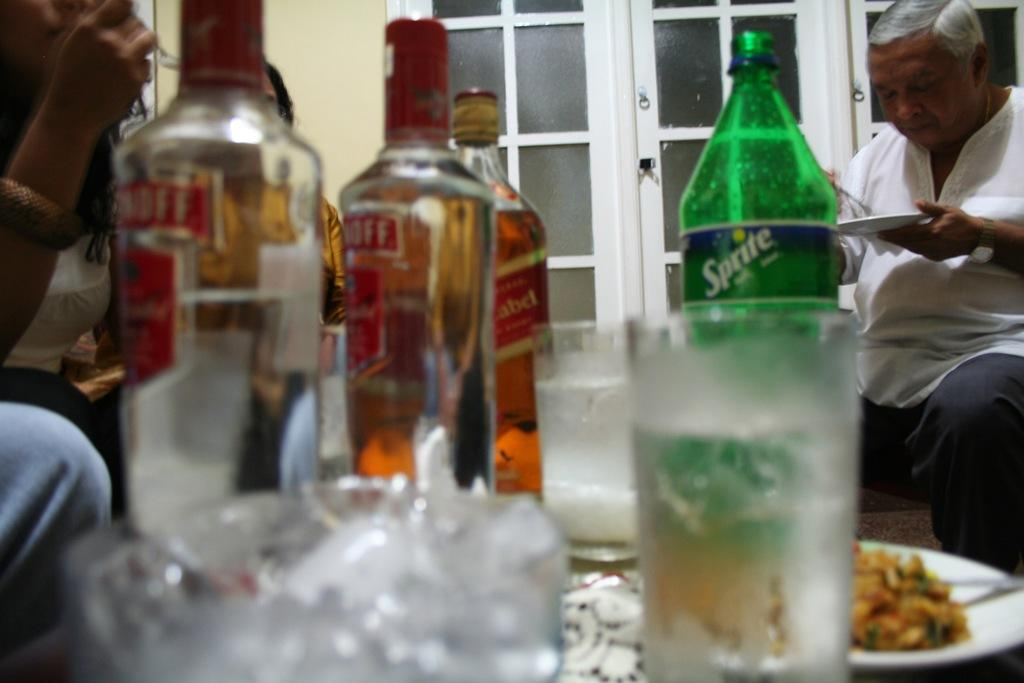<image>
Present a compact description of the photo's key features. A TABLE WITH FOOD AND SEVERAL BOTTLES OF SMIRNOFFF LIQUOR BOTTLES 